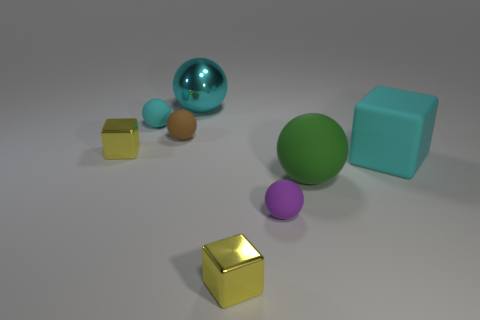There is a tiny cyan matte object; is its shape the same as the cyan matte object to the right of the cyan rubber ball?
Provide a short and direct response. No. There is a cyan rubber object that is the same shape as the small brown object; what size is it?
Offer a very short reply. Small. There is a metal sphere; does it have the same color as the big rubber thing left of the big matte block?
Offer a terse response. No. What number of other things are the same size as the cyan metal sphere?
Provide a short and direct response. 2. What is the shape of the yellow thing behind the yellow shiny cube that is in front of the tiny cube that is to the left of the tiny cyan matte ball?
Offer a terse response. Cube. There is a brown sphere; is its size the same as the thing on the left side of the tiny cyan sphere?
Offer a very short reply. Yes. There is a block that is both left of the purple matte thing and behind the large green sphere; what is its color?
Ensure brevity in your answer.  Yellow. What number of other objects are the same shape as the big green matte object?
Your response must be concise. 4. Does the small rubber thing in front of the small brown matte sphere have the same color as the large object that is behind the matte cube?
Provide a succinct answer. No. Does the yellow shiny thing that is behind the purple rubber sphere have the same size as the cyan metal sphere that is on the left side of the large green matte ball?
Your response must be concise. No. 